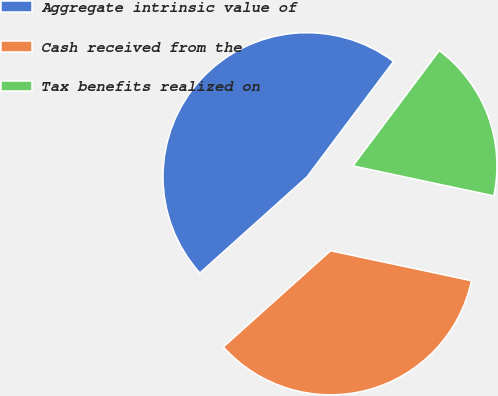<chart> <loc_0><loc_0><loc_500><loc_500><pie_chart><fcel>Aggregate intrinsic value of<fcel>Cash received from the<fcel>Tax benefits realized on<nl><fcel>46.88%<fcel>35.02%<fcel>18.1%<nl></chart> 